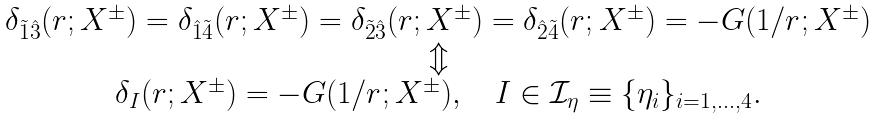<formula> <loc_0><loc_0><loc_500><loc_500>\begin{array} { c } \delta _ { \tilde { 1 } \hat { 3 } } ( r ; X ^ { \pm } ) = \delta _ { \hat { 1 } \tilde { 4 } } ( r ; X ^ { \pm } ) = \delta _ { \tilde { 2 } \hat { 3 } } ( r ; X ^ { \pm } ) = \delta _ { \hat { 2 } \tilde { 4 } } ( r ; X ^ { \pm } ) = - G ( 1 / r ; X ^ { \pm } ) \\ \Updownarrow \\ \delta _ { I } ( r ; X ^ { \pm } ) = - G ( 1 / r ; X ^ { \pm } ) , \quad I \in \mathcal { I } _ { \eta } \equiv \{ \eta _ { i } \} _ { i = 1 , \dots , 4 } . \end{array}</formula> 